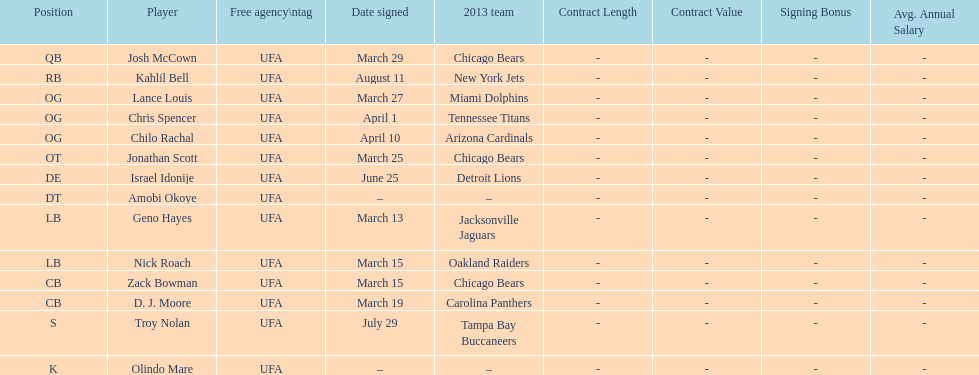Would you mind parsing the complete table? {'header': ['Position', 'Player', 'Free agency\\ntag', 'Date signed', '2013 team', 'Contract Length', 'Contract Value', 'Signing Bonus', 'Avg. Annual Salary'], 'rows': [['QB', 'Josh McCown', 'UFA', 'March 29', 'Chicago Bears', '-', '-', '-', '-'], ['RB', 'Kahlil Bell', 'UFA', 'August 11', 'New York Jets', '-', '-', '-', '-'], ['OG', 'Lance Louis', 'UFA', 'March 27', 'Miami Dolphins', '-', '-', '-', '-'], ['OG', 'Chris Spencer', 'UFA', 'April 1', 'Tennessee Titans', '-', '-', '-', '-'], ['OG', 'Chilo Rachal', 'UFA', 'April 10', 'Arizona Cardinals', '-', '-', '-', '-'], ['OT', 'Jonathan Scott', 'UFA', 'March 25', 'Chicago Bears', '-', '-', '-', '-'], ['DE', 'Israel Idonije', 'UFA', 'June 25', 'Detroit Lions', '-', '-', '-', '-'], ['DT', 'Amobi Okoye', 'UFA', '–', '–', '-', '-', '-', '-'], ['LB', 'Geno Hayes', 'UFA', 'March 13', 'Jacksonville Jaguars', '-', '-', '-', '-'], ['LB', 'Nick Roach', 'UFA', 'March 15', 'Oakland Raiders', '-', '-', '-', '-'], ['CB', 'Zack Bowman', 'UFA', 'March 15', 'Chicago Bears', '-', '-', '-', '-'], ['CB', 'D. J. Moore', 'UFA', 'March 19', 'Carolina Panthers', '-', '-', '-', '-'], ['S', 'Troy Nolan', 'UFA', 'July 29', 'Tampa Bay Buccaneers', '-', '-', '-', '-'], ['K', 'Olindo Mare', 'UFA', '–', '–', '-', '-', '-', '-']]} The highest played position based on this graph. OG. 